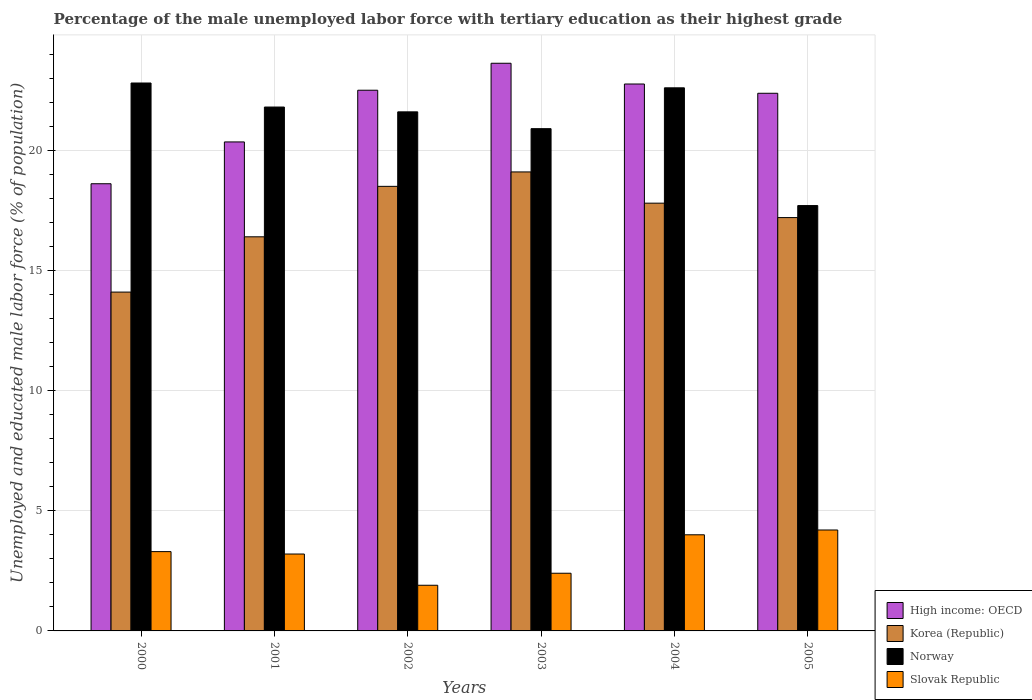How many different coloured bars are there?
Offer a very short reply. 4. How many groups of bars are there?
Your answer should be very brief. 6. Are the number of bars per tick equal to the number of legend labels?
Give a very brief answer. Yes. How many bars are there on the 1st tick from the left?
Keep it short and to the point. 4. How many bars are there on the 6th tick from the right?
Provide a short and direct response. 4. In how many cases, is the number of bars for a given year not equal to the number of legend labels?
Provide a succinct answer. 0. What is the percentage of the unemployed male labor force with tertiary education in Korea (Republic) in 2005?
Give a very brief answer. 17.2. Across all years, what is the maximum percentage of the unemployed male labor force with tertiary education in Norway?
Ensure brevity in your answer.  22.8. Across all years, what is the minimum percentage of the unemployed male labor force with tertiary education in Norway?
Give a very brief answer. 17.7. In which year was the percentage of the unemployed male labor force with tertiary education in Norway maximum?
Ensure brevity in your answer.  2000. What is the total percentage of the unemployed male labor force with tertiary education in Korea (Republic) in the graph?
Your answer should be very brief. 103.1. What is the difference between the percentage of the unemployed male labor force with tertiary education in High income: OECD in 2001 and that in 2005?
Offer a very short reply. -2.02. What is the difference between the percentage of the unemployed male labor force with tertiary education in Slovak Republic in 2005 and the percentage of the unemployed male labor force with tertiary education in High income: OECD in 2003?
Provide a succinct answer. -19.42. What is the average percentage of the unemployed male labor force with tertiary education in Norway per year?
Provide a short and direct response. 21.23. In the year 2005, what is the difference between the percentage of the unemployed male labor force with tertiary education in Slovak Republic and percentage of the unemployed male labor force with tertiary education in Norway?
Your answer should be compact. -13.5. What is the ratio of the percentage of the unemployed male labor force with tertiary education in Slovak Republic in 2001 to that in 2005?
Make the answer very short. 0.76. What is the difference between the highest and the second highest percentage of the unemployed male labor force with tertiary education in Norway?
Offer a terse response. 0.2. What is the difference between the highest and the lowest percentage of the unemployed male labor force with tertiary education in Norway?
Provide a succinct answer. 5.1. In how many years, is the percentage of the unemployed male labor force with tertiary education in Korea (Republic) greater than the average percentage of the unemployed male labor force with tertiary education in Korea (Republic) taken over all years?
Give a very brief answer. 4. Is the sum of the percentage of the unemployed male labor force with tertiary education in High income: OECD in 2003 and 2004 greater than the maximum percentage of the unemployed male labor force with tertiary education in Korea (Republic) across all years?
Keep it short and to the point. Yes. What does the 3rd bar from the right in 2002 represents?
Offer a very short reply. Korea (Republic). Are all the bars in the graph horizontal?
Provide a short and direct response. No. How many years are there in the graph?
Provide a short and direct response. 6. Are the values on the major ticks of Y-axis written in scientific E-notation?
Keep it short and to the point. No. Where does the legend appear in the graph?
Your answer should be very brief. Bottom right. What is the title of the graph?
Your response must be concise. Percentage of the male unemployed labor force with tertiary education as their highest grade. What is the label or title of the Y-axis?
Give a very brief answer. Unemployed and educated male labor force (% of population). What is the Unemployed and educated male labor force (% of population) in High income: OECD in 2000?
Offer a very short reply. 18.61. What is the Unemployed and educated male labor force (% of population) of Korea (Republic) in 2000?
Make the answer very short. 14.1. What is the Unemployed and educated male labor force (% of population) of Norway in 2000?
Offer a terse response. 22.8. What is the Unemployed and educated male labor force (% of population) of Slovak Republic in 2000?
Offer a very short reply. 3.3. What is the Unemployed and educated male labor force (% of population) of High income: OECD in 2001?
Your response must be concise. 20.35. What is the Unemployed and educated male labor force (% of population) in Korea (Republic) in 2001?
Ensure brevity in your answer.  16.4. What is the Unemployed and educated male labor force (% of population) of Norway in 2001?
Offer a very short reply. 21.8. What is the Unemployed and educated male labor force (% of population) of Slovak Republic in 2001?
Your answer should be very brief. 3.2. What is the Unemployed and educated male labor force (% of population) of High income: OECD in 2002?
Keep it short and to the point. 22.5. What is the Unemployed and educated male labor force (% of population) in Norway in 2002?
Your answer should be very brief. 21.6. What is the Unemployed and educated male labor force (% of population) of Slovak Republic in 2002?
Make the answer very short. 1.9. What is the Unemployed and educated male labor force (% of population) of High income: OECD in 2003?
Your answer should be compact. 23.62. What is the Unemployed and educated male labor force (% of population) of Korea (Republic) in 2003?
Keep it short and to the point. 19.1. What is the Unemployed and educated male labor force (% of population) in Norway in 2003?
Ensure brevity in your answer.  20.9. What is the Unemployed and educated male labor force (% of population) in Slovak Republic in 2003?
Provide a short and direct response. 2.4. What is the Unemployed and educated male labor force (% of population) in High income: OECD in 2004?
Keep it short and to the point. 22.76. What is the Unemployed and educated male labor force (% of population) in Korea (Republic) in 2004?
Offer a terse response. 17.8. What is the Unemployed and educated male labor force (% of population) of Norway in 2004?
Provide a succinct answer. 22.6. What is the Unemployed and educated male labor force (% of population) in Slovak Republic in 2004?
Offer a very short reply. 4. What is the Unemployed and educated male labor force (% of population) in High income: OECD in 2005?
Your response must be concise. 22.37. What is the Unemployed and educated male labor force (% of population) in Korea (Republic) in 2005?
Provide a short and direct response. 17.2. What is the Unemployed and educated male labor force (% of population) in Norway in 2005?
Provide a succinct answer. 17.7. What is the Unemployed and educated male labor force (% of population) in Slovak Republic in 2005?
Your answer should be very brief. 4.2. Across all years, what is the maximum Unemployed and educated male labor force (% of population) in High income: OECD?
Your response must be concise. 23.62. Across all years, what is the maximum Unemployed and educated male labor force (% of population) of Korea (Republic)?
Give a very brief answer. 19.1. Across all years, what is the maximum Unemployed and educated male labor force (% of population) of Norway?
Provide a succinct answer. 22.8. Across all years, what is the maximum Unemployed and educated male labor force (% of population) in Slovak Republic?
Your response must be concise. 4.2. Across all years, what is the minimum Unemployed and educated male labor force (% of population) in High income: OECD?
Provide a short and direct response. 18.61. Across all years, what is the minimum Unemployed and educated male labor force (% of population) of Korea (Republic)?
Your answer should be compact. 14.1. Across all years, what is the minimum Unemployed and educated male labor force (% of population) in Norway?
Give a very brief answer. 17.7. Across all years, what is the minimum Unemployed and educated male labor force (% of population) of Slovak Republic?
Keep it short and to the point. 1.9. What is the total Unemployed and educated male labor force (% of population) in High income: OECD in the graph?
Your answer should be very brief. 130.21. What is the total Unemployed and educated male labor force (% of population) of Korea (Republic) in the graph?
Provide a short and direct response. 103.1. What is the total Unemployed and educated male labor force (% of population) of Norway in the graph?
Give a very brief answer. 127.4. What is the total Unemployed and educated male labor force (% of population) of Slovak Republic in the graph?
Make the answer very short. 19. What is the difference between the Unemployed and educated male labor force (% of population) in High income: OECD in 2000 and that in 2001?
Give a very brief answer. -1.74. What is the difference between the Unemployed and educated male labor force (% of population) in Korea (Republic) in 2000 and that in 2001?
Offer a very short reply. -2.3. What is the difference between the Unemployed and educated male labor force (% of population) in Slovak Republic in 2000 and that in 2001?
Your answer should be compact. 0.1. What is the difference between the Unemployed and educated male labor force (% of population) of High income: OECD in 2000 and that in 2002?
Ensure brevity in your answer.  -3.89. What is the difference between the Unemployed and educated male labor force (% of population) of Norway in 2000 and that in 2002?
Provide a succinct answer. 1.2. What is the difference between the Unemployed and educated male labor force (% of population) in Slovak Republic in 2000 and that in 2002?
Your answer should be very brief. 1.4. What is the difference between the Unemployed and educated male labor force (% of population) of High income: OECD in 2000 and that in 2003?
Give a very brief answer. -5.01. What is the difference between the Unemployed and educated male labor force (% of population) in Norway in 2000 and that in 2003?
Ensure brevity in your answer.  1.9. What is the difference between the Unemployed and educated male labor force (% of population) in Slovak Republic in 2000 and that in 2003?
Offer a terse response. 0.9. What is the difference between the Unemployed and educated male labor force (% of population) in High income: OECD in 2000 and that in 2004?
Offer a very short reply. -4.15. What is the difference between the Unemployed and educated male labor force (% of population) in Korea (Republic) in 2000 and that in 2004?
Give a very brief answer. -3.7. What is the difference between the Unemployed and educated male labor force (% of population) of Norway in 2000 and that in 2004?
Offer a very short reply. 0.2. What is the difference between the Unemployed and educated male labor force (% of population) in High income: OECD in 2000 and that in 2005?
Keep it short and to the point. -3.76. What is the difference between the Unemployed and educated male labor force (% of population) in Norway in 2000 and that in 2005?
Ensure brevity in your answer.  5.1. What is the difference between the Unemployed and educated male labor force (% of population) of Slovak Republic in 2000 and that in 2005?
Your response must be concise. -0.9. What is the difference between the Unemployed and educated male labor force (% of population) in High income: OECD in 2001 and that in 2002?
Provide a succinct answer. -2.15. What is the difference between the Unemployed and educated male labor force (% of population) in Slovak Republic in 2001 and that in 2002?
Your response must be concise. 1.3. What is the difference between the Unemployed and educated male labor force (% of population) in High income: OECD in 2001 and that in 2003?
Give a very brief answer. -3.27. What is the difference between the Unemployed and educated male labor force (% of population) of Korea (Republic) in 2001 and that in 2003?
Your response must be concise. -2.7. What is the difference between the Unemployed and educated male labor force (% of population) in Norway in 2001 and that in 2003?
Offer a terse response. 0.9. What is the difference between the Unemployed and educated male labor force (% of population) of Slovak Republic in 2001 and that in 2003?
Make the answer very short. 0.8. What is the difference between the Unemployed and educated male labor force (% of population) in High income: OECD in 2001 and that in 2004?
Offer a very short reply. -2.41. What is the difference between the Unemployed and educated male labor force (% of population) in Korea (Republic) in 2001 and that in 2004?
Your answer should be compact. -1.4. What is the difference between the Unemployed and educated male labor force (% of population) of Norway in 2001 and that in 2004?
Make the answer very short. -0.8. What is the difference between the Unemployed and educated male labor force (% of population) in Slovak Republic in 2001 and that in 2004?
Offer a very short reply. -0.8. What is the difference between the Unemployed and educated male labor force (% of population) of High income: OECD in 2001 and that in 2005?
Give a very brief answer. -2.02. What is the difference between the Unemployed and educated male labor force (% of population) in High income: OECD in 2002 and that in 2003?
Give a very brief answer. -1.12. What is the difference between the Unemployed and educated male labor force (% of population) in Korea (Republic) in 2002 and that in 2003?
Provide a short and direct response. -0.6. What is the difference between the Unemployed and educated male labor force (% of population) in High income: OECD in 2002 and that in 2004?
Provide a short and direct response. -0.26. What is the difference between the Unemployed and educated male labor force (% of population) in Korea (Republic) in 2002 and that in 2004?
Give a very brief answer. 0.7. What is the difference between the Unemployed and educated male labor force (% of population) in Norway in 2002 and that in 2004?
Ensure brevity in your answer.  -1. What is the difference between the Unemployed and educated male labor force (% of population) of High income: OECD in 2002 and that in 2005?
Give a very brief answer. 0.13. What is the difference between the Unemployed and educated male labor force (% of population) in Korea (Republic) in 2002 and that in 2005?
Give a very brief answer. 1.3. What is the difference between the Unemployed and educated male labor force (% of population) of High income: OECD in 2003 and that in 2004?
Provide a succinct answer. 0.86. What is the difference between the Unemployed and educated male labor force (% of population) in Korea (Republic) in 2003 and that in 2004?
Make the answer very short. 1.3. What is the difference between the Unemployed and educated male labor force (% of population) in High income: OECD in 2003 and that in 2005?
Your answer should be compact. 1.25. What is the difference between the Unemployed and educated male labor force (% of population) of Korea (Republic) in 2003 and that in 2005?
Your response must be concise. 1.9. What is the difference between the Unemployed and educated male labor force (% of population) in Norway in 2003 and that in 2005?
Give a very brief answer. 3.2. What is the difference between the Unemployed and educated male labor force (% of population) of High income: OECD in 2004 and that in 2005?
Give a very brief answer. 0.39. What is the difference between the Unemployed and educated male labor force (% of population) in Korea (Republic) in 2004 and that in 2005?
Make the answer very short. 0.6. What is the difference between the Unemployed and educated male labor force (% of population) in Norway in 2004 and that in 2005?
Your answer should be very brief. 4.9. What is the difference between the Unemployed and educated male labor force (% of population) in Slovak Republic in 2004 and that in 2005?
Ensure brevity in your answer.  -0.2. What is the difference between the Unemployed and educated male labor force (% of population) in High income: OECD in 2000 and the Unemployed and educated male labor force (% of population) in Korea (Republic) in 2001?
Make the answer very short. 2.21. What is the difference between the Unemployed and educated male labor force (% of population) in High income: OECD in 2000 and the Unemployed and educated male labor force (% of population) in Norway in 2001?
Make the answer very short. -3.19. What is the difference between the Unemployed and educated male labor force (% of population) of High income: OECD in 2000 and the Unemployed and educated male labor force (% of population) of Slovak Republic in 2001?
Your answer should be very brief. 15.41. What is the difference between the Unemployed and educated male labor force (% of population) in Korea (Republic) in 2000 and the Unemployed and educated male labor force (% of population) in Norway in 2001?
Offer a very short reply. -7.7. What is the difference between the Unemployed and educated male labor force (% of population) of Korea (Republic) in 2000 and the Unemployed and educated male labor force (% of population) of Slovak Republic in 2001?
Ensure brevity in your answer.  10.9. What is the difference between the Unemployed and educated male labor force (% of population) in Norway in 2000 and the Unemployed and educated male labor force (% of population) in Slovak Republic in 2001?
Offer a very short reply. 19.6. What is the difference between the Unemployed and educated male labor force (% of population) of High income: OECD in 2000 and the Unemployed and educated male labor force (% of population) of Korea (Republic) in 2002?
Ensure brevity in your answer.  0.11. What is the difference between the Unemployed and educated male labor force (% of population) in High income: OECD in 2000 and the Unemployed and educated male labor force (% of population) in Norway in 2002?
Provide a short and direct response. -2.99. What is the difference between the Unemployed and educated male labor force (% of population) in High income: OECD in 2000 and the Unemployed and educated male labor force (% of population) in Slovak Republic in 2002?
Make the answer very short. 16.71. What is the difference between the Unemployed and educated male labor force (% of population) of Korea (Republic) in 2000 and the Unemployed and educated male labor force (% of population) of Norway in 2002?
Your answer should be compact. -7.5. What is the difference between the Unemployed and educated male labor force (% of population) in Norway in 2000 and the Unemployed and educated male labor force (% of population) in Slovak Republic in 2002?
Provide a succinct answer. 20.9. What is the difference between the Unemployed and educated male labor force (% of population) in High income: OECD in 2000 and the Unemployed and educated male labor force (% of population) in Korea (Republic) in 2003?
Provide a succinct answer. -0.49. What is the difference between the Unemployed and educated male labor force (% of population) in High income: OECD in 2000 and the Unemployed and educated male labor force (% of population) in Norway in 2003?
Provide a short and direct response. -2.29. What is the difference between the Unemployed and educated male labor force (% of population) in High income: OECD in 2000 and the Unemployed and educated male labor force (% of population) in Slovak Republic in 2003?
Offer a very short reply. 16.21. What is the difference between the Unemployed and educated male labor force (% of population) of Korea (Republic) in 2000 and the Unemployed and educated male labor force (% of population) of Norway in 2003?
Ensure brevity in your answer.  -6.8. What is the difference between the Unemployed and educated male labor force (% of population) in Korea (Republic) in 2000 and the Unemployed and educated male labor force (% of population) in Slovak Republic in 2003?
Your answer should be compact. 11.7. What is the difference between the Unemployed and educated male labor force (% of population) of Norway in 2000 and the Unemployed and educated male labor force (% of population) of Slovak Republic in 2003?
Offer a terse response. 20.4. What is the difference between the Unemployed and educated male labor force (% of population) of High income: OECD in 2000 and the Unemployed and educated male labor force (% of population) of Korea (Republic) in 2004?
Keep it short and to the point. 0.81. What is the difference between the Unemployed and educated male labor force (% of population) of High income: OECD in 2000 and the Unemployed and educated male labor force (% of population) of Norway in 2004?
Your answer should be very brief. -3.99. What is the difference between the Unemployed and educated male labor force (% of population) in High income: OECD in 2000 and the Unemployed and educated male labor force (% of population) in Slovak Republic in 2004?
Your answer should be very brief. 14.61. What is the difference between the Unemployed and educated male labor force (% of population) in Korea (Republic) in 2000 and the Unemployed and educated male labor force (% of population) in Slovak Republic in 2004?
Offer a very short reply. 10.1. What is the difference between the Unemployed and educated male labor force (% of population) of Norway in 2000 and the Unemployed and educated male labor force (% of population) of Slovak Republic in 2004?
Give a very brief answer. 18.8. What is the difference between the Unemployed and educated male labor force (% of population) of High income: OECD in 2000 and the Unemployed and educated male labor force (% of population) of Korea (Republic) in 2005?
Offer a very short reply. 1.41. What is the difference between the Unemployed and educated male labor force (% of population) of High income: OECD in 2000 and the Unemployed and educated male labor force (% of population) of Norway in 2005?
Ensure brevity in your answer.  0.91. What is the difference between the Unemployed and educated male labor force (% of population) of High income: OECD in 2000 and the Unemployed and educated male labor force (% of population) of Slovak Republic in 2005?
Your answer should be compact. 14.41. What is the difference between the Unemployed and educated male labor force (% of population) in Korea (Republic) in 2000 and the Unemployed and educated male labor force (% of population) in Norway in 2005?
Offer a very short reply. -3.6. What is the difference between the Unemployed and educated male labor force (% of population) in Norway in 2000 and the Unemployed and educated male labor force (% of population) in Slovak Republic in 2005?
Your answer should be very brief. 18.6. What is the difference between the Unemployed and educated male labor force (% of population) of High income: OECD in 2001 and the Unemployed and educated male labor force (% of population) of Korea (Republic) in 2002?
Provide a short and direct response. 1.85. What is the difference between the Unemployed and educated male labor force (% of population) in High income: OECD in 2001 and the Unemployed and educated male labor force (% of population) in Norway in 2002?
Your response must be concise. -1.25. What is the difference between the Unemployed and educated male labor force (% of population) of High income: OECD in 2001 and the Unemployed and educated male labor force (% of population) of Slovak Republic in 2002?
Keep it short and to the point. 18.45. What is the difference between the Unemployed and educated male labor force (% of population) of Korea (Republic) in 2001 and the Unemployed and educated male labor force (% of population) of Slovak Republic in 2002?
Give a very brief answer. 14.5. What is the difference between the Unemployed and educated male labor force (% of population) of High income: OECD in 2001 and the Unemployed and educated male labor force (% of population) of Korea (Republic) in 2003?
Make the answer very short. 1.25. What is the difference between the Unemployed and educated male labor force (% of population) of High income: OECD in 2001 and the Unemployed and educated male labor force (% of population) of Norway in 2003?
Your answer should be compact. -0.55. What is the difference between the Unemployed and educated male labor force (% of population) in High income: OECD in 2001 and the Unemployed and educated male labor force (% of population) in Slovak Republic in 2003?
Ensure brevity in your answer.  17.95. What is the difference between the Unemployed and educated male labor force (% of population) of Norway in 2001 and the Unemployed and educated male labor force (% of population) of Slovak Republic in 2003?
Offer a very short reply. 19.4. What is the difference between the Unemployed and educated male labor force (% of population) in High income: OECD in 2001 and the Unemployed and educated male labor force (% of population) in Korea (Republic) in 2004?
Your answer should be very brief. 2.55. What is the difference between the Unemployed and educated male labor force (% of population) of High income: OECD in 2001 and the Unemployed and educated male labor force (% of population) of Norway in 2004?
Offer a terse response. -2.25. What is the difference between the Unemployed and educated male labor force (% of population) of High income: OECD in 2001 and the Unemployed and educated male labor force (% of population) of Slovak Republic in 2004?
Offer a terse response. 16.35. What is the difference between the Unemployed and educated male labor force (% of population) in Norway in 2001 and the Unemployed and educated male labor force (% of population) in Slovak Republic in 2004?
Offer a very short reply. 17.8. What is the difference between the Unemployed and educated male labor force (% of population) of High income: OECD in 2001 and the Unemployed and educated male labor force (% of population) of Korea (Republic) in 2005?
Your response must be concise. 3.15. What is the difference between the Unemployed and educated male labor force (% of population) of High income: OECD in 2001 and the Unemployed and educated male labor force (% of population) of Norway in 2005?
Your answer should be compact. 2.65. What is the difference between the Unemployed and educated male labor force (% of population) of High income: OECD in 2001 and the Unemployed and educated male labor force (% of population) of Slovak Republic in 2005?
Provide a succinct answer. 16.15. What is the difference between the Unemployed and educated male labor force (% of population) of Korea (Republic) in 2001 and the Unemployed and educated male labor force (% of population) of Slovak Republic in 2005?
Make the answer very short. 12.2. What is the difference between the Unemployed and educated male labor force (% of population) in High income: OECD in 2002 and the Unemployed and educated male labor force (% of population) in Korea (Republic) in 2003?
Provide a succinct answer. 3.4. What is the difference between the Unemployed and educated male labor force (% of population) in High income: OECD in 2002 and the Unemployed and educated male labor force (% of population) in Norway in 2003?
Your answer should be compact. 1.6. What is the difference between the Unemployed and educated male labor force (% of population) of High income: OECD in 2002 and the Unemployed and educated male labor force (% of population) of Slovak Republic in 2003?
Keep it short and to the point. 20.1. What is the difference between the Unemployed and educated male labor force (% of population) of Korea (Republic) in 2002 and the Unemployed and educated male labor force (% of population) of Norway in 2003?
Make the answer very short. -2.4. What is the difference between the Unemployed and educated male labor force (% of population) in Korea (Republic) in 2002 and the Unemployed and educated male labor force (% of population) in Slovak Republic in 2003?
Offer a terse response. 16.1. What is the difference between the Unemployed and educated male labor force (% of population) of Norway in 2002 and the Unemployed and educated male labor force (% of population) of Slovak Republic in 2003?
Provide a short and direct response. 19.2. What is the difference between the Unemployed and educated male labor force (% of population) of High income: OECD in 2002 and the Unemployed and educated male labor force (% of population) of Korea (Republic) in 2004?
Provide a succinct answer. 4.7. What is the difference between the Unemployed and educated male labor force (% of population) of High income: OECD in 2002 and the Unemployed and educated male labor force (% of population) of Norway in 2004?
Your answer should be compact. -0.1. What is the difference between the Unemployed and educated male labor force (% of population) of High income: OECD in 2002 and the Unemployed and educated male labor force (% of population) of Slovak Republic in 2004?
Make the answer very short. 18.5. What is the difference between the Unemployed and educated male labor force (% of population) of High income: OECD in 2002 and the Unemployed and educated male labor force (% of population) of Korea (Republic) in 2005?
Give a very brief answer. 5.3. What is the difference between the Unemployed and educated male labor force (% of population) of High income: OECD in 2002 and the Unemployed and educated male labor force (% of population) of Norway in 2005?
Your answer should be compact. 4.8. What is the difference between the Unemployed and educated male labor force (% of population) in High income: OECD in 2002 and the Unemployed and educated male labor force (% of population) in Slovak Republic in 2005?
Provide a succinct answer. 18.3. What is the difference between the Unemployed and educated male labor force (% of population) of Korea (Republic) in 2002 and the Unemployed and educated male labor force (% of population) of Norway in 2005?
Your answer should be very brief. 0.8. What is the difference between the Unemployed and educated male labor force (% of population) in High income: OECD in 2003 and the Unemployed and educated male labor force (% of population) in Korea (Republic) in 2004?
Offer a terse response. 5.82. What is the difference between the Unemployed and educated male labor force (% of population) of High income: OECD in 2003 and the Unemployed and educated male labor force (% of population) of Norway in 2004?
Offer a very short reply. 1.02. What is the difference between the Unemployed and educated male labor force (% of population) of High income: OECD in 2003 and the Unemployed and educated male labor force (% of population) of Slovak Republic in 2004?
Make the answer very short. 19.62. What is the difference between the Unemployed and educated male labor force (% of population) in High income: OECD in 2003 and the Unemployed and educated male labor force (% of population) in Korea (Republic) in 2005?
Offer a terse response. 6.42. What is the difference between the Unemployed and educated male labor force (% of population) of High income: OECD in 2003 and the Unemployed and educated male labor force (% of population) of Norway in 2005?
Give a very brief answer. 5.92. What is the difference between the Unemployed and educated male labor force (% of population) of High income: OECD in 2003 and the Unemployed and educated male labor force (% of population) of Slovak Republic in 2005?
Give a very brief answer. 19.42. What is the difference between the Unemployed and educated male labor force (% of population) in Norway in 2003 and the Unemployed and educated male labor force (% of population) in Slovak Republic in 2005?
Ensure brevity in your answer.  16.7. What is the difference between the Unemployed and educated male labor force (% of population) in High income: OECD in 2004 and the Unemployed and educated male labor force (% of population) in Korea (Republic) in 2005?
Give a very brief answer. 5.56. What is the difference between the Unemployed and educated male labor force (% of population) in High income: OECD in 2004 and the Unemployed and educated male labor force (% of population) in Norway in 2005?
Provide a short and direct response. 5.06. What is the difference between the Unemployed and educated male labor force (% of population) in High income: OECD in 2004 and the Unemployed and educated male labor force (% of population) in Slovak Republic in 2005?
Offer a terse response. 18.56. What is the average Unemployed and educated male labor force (% of population) of High income: OECD per year?
Your answer should be very brief. 21.7. What is the average Unemployed and educated male labor force (% of population) in Korea (Republic) per year?
Your answer should be very brief. 17.18. What is the average Unemployed and educated male labor force (% of population) of Norway per year?
Your answer should be very brief. 21.23. What is the average Unemployed and educated male labor force (% of population) of Slovak Republic per year?
Offer a very short reply. 3.17. In the year 2000, what is the difference between the Unemployed and educated male labor force (% of population) in High income: OECD and Unemployed and educated male labor force (% of population) in Korea (Republic)?
Your response must be concise. 4.51. In the year 2000, what is the difference between the Unemployed and educated male labor force (% of population) in High income: OECD and Unemployed and educated male labor force (% of population) in Norway?
Your answer should be very brief. -4.19. In the year 2000, what is the difference between the Unemployed and educated male labor force (% of population) in High income: OECD and Unemployed and educated male labor force (% of population) in Slovak Republic?
Your answer should be very brief. 15.31. In the year 2001, what is the difference between the Unemployed and educated male labor force (% of population) in High income: OECD and Unemployed and educated male labor force (% of population) in Korea (Republic)?
Offer a very short reply. 3.95. In the year 2001, what is the difference between the Unemployed and educated male labor force (% of population) of High income: OECD and Unemployed and educated male labor force (% of population) of Norway?
Keep it short and to the point. -1.45. In the year 2001, what is the difference between the Unemployed and educated male labor force (% of population) in High income: OECD and Unemployed and educated male labor force (% of population) in Slovak Republic?
Your answer should be compact. 17.15. In the year 2002, what is the difference between the Unemployed and educated male labor force (% of population) in High income: OECD and Unemployed and educated male labor force (% of population) in Korea (Republic)?
Provide a succinct answer. 4. In the year 2002, what is the difference between the Unemployed and educated male labor force (% of population) in High income: OECD and Unemployed and educated male labor force (% of population) in Norway?
Provide a succinct answer. 0.9. In the year 2002, what is the difference between the Unemployed and educated male labor force (% of population) of High income: OECD and Unemployed and educated male labor force (% of population) of Slovak Republic?
Ensure brevity in your answer.  20.6. In the year 2002, what is the difference between the Unemployed and educated male labor force (% of population) of Korea (Republic) and Unemployed and educated male labor force (% of population) of Norway?
Your answer should be very brief. -3.1. In the year 2003, what is the difference between the Unemployed and educated male labor force (% of population) in High income: OECD and Unemployed and educated male labor force (% of population) in Korea (Republic)?
Give a very brief answer. 4.52. In the year 2003, what is the difference between the Unemployed and educated male labor force (% of population) of High income: OECD and Unemployed and educated male labor force (% of population) of Norway?
Ensure brevity in your answer.  2.72. In the year 2003, what is the difference between the Unemployed and educated male labor force (% of population) of High income: OECD and Unemployed and educated male labor force (% of population) of Slovak Republic?
Your response must be concise. 21.22. In the year 2003, what is the difference between the Unemployed and educated male labor force (% of population) in Korea (Republic) and Unemployed and educated male labor force (% of population) in Norway?
Your response must be concise. -1.8. In the year 2003, what is the difference between the Unemployed and educated male labor force (% of population) of Norway and Unemployed and educated male labor force (% of population) of Slovak Republic?
Provide a succinct answer. 18.5. In the year 2004, what is the difference between the Unemployed and educated male labor force (% of population) in High income: OECD and Unemployed and educated male labor force (% of population) in Korea (Republic)?
Offer a terse response. 4.96. In the year 2004, what is the difference between the Unemployed and educated male labor force (% of population) of High income: OECD and Unemployed and educated male labor force (% of population) of Norway?
Offer a terse response. 0.16. In the year 2004, what is the difference between the Unemployed and educated male labor force (% of population) in High income: OECD and Unemployed and educated male labor force (% of population) in Slovak Republic?
Make the answer very short. 18.76. In the year 2004, what is the difference between the Unemployed and educated male labor force (% of population) of Korea (Republic) and Unemployed and educated male labor force (% of population) of Slovak Republic?
Offer a very short reply. 13.8. In the year 2005, what is the difference between the Unemployed and educated male labor force (% of population) in High income: OECD and Unemployed and educated male labor force (% of population) in Korea (Republic)?
Your response must be concise. 5.17. In the year 2005, what is the difference between the Unemployed and educated male labor force (% of population) of High income: OECD and Unemployed and educated male labor force (% of population) of Norway?
Your response must be concise. 4.67. In the year 2005, what is the difference between the Unemployed and educated male labor force (% of population) of High income: OECD and Unemployed and educated male labor force (% of population) of Slovak Republic?
Keep it short and to the point. 18.17. What is the ratio of the Unemployed and educated male labor force (% of population) of High income: OECD in 2000 to that in 2001?
Make the answer very short. 0.91. What is the ratio of the Unemployed and educated male labor force (% of population) in Korea (Republic) in 2000 to that in 2001?
Give a very brief answer. 0.86. What is the ratio of the Unemployed and educated male labor force (% of population) in Norway in 2000 to that in 2001?
Provide a succinct answer. 1.05. What is the ratio of the Unemployed and educated male labor force (% of population) in Slovak Republic in 2000 to that in 2001?
Your answer should be compact. 1.03. What is the ratio of the Unemployed and educated male labor force (% of population) of High income: OECD in 2000 to that in 2002?
Your answer should be very brief. 0.83. What is the ratio of the Unemployed and educated male labor force (% of population) of Korea (Republic) in 2000 to that in 2002?
Provide a short and direct response. 0.76. What is the ratio of the Unemployed and educated male labor force (% of population) of Norway in 2000 to that in 2002?
Ensure brevity in your answer.  1.06. What is the ratio of the Unemployed and educated male labor force (% of population) in Slovak Republic in 2000 to that in 2002?
Give a very brief answer. 1.74. What is the ratio of the Unemployed and educated male labor force (% of population) in High income: OECD in 2000 to that in 2003?
Offer a terse response. 0.79. What is the ratio of the Unemployed and educated male labor force (% of population) in Korea (Republic) in 2000 to that in 2003?
Ensure brevity in your answer.  0.74. What is the ratio of the Unemployed and educated male labor force (% of population) of Slovak Republic in 2000 to that in 2003?
Make the answer very short. 1.38. What is the ratio of the Unemployed and educated male labor force (% of population) in High income: OECD in 2000 to that in 2004?
Give a very brief answer. 0.82. What is the ratio of the Unemployed and educated male labor force (% of population) of Korea (Republic) in 2000 to that in 2004?
Offer a terse response. 0.79. What is the ratio of the Unemployed and educated male labor force (% of population) in Norway in 2000 to that in 2004?
Your answer should be very brief. 1.01. What is the ratio of the Unemployed and educated male labor force (% of population) of Slovak Republic in 2000 to that in 2004?
Your response must be concise. 0.82. What is the ratio of the Unemployed and educated male labor force (% of population) of High income: OECD in 2000 to that in 2005?
Provide a succinct answer. 0.83. What is the ratio of the Unemployed and educated male labor force (% of population) of Korea (Republic) in 2000 to that in 2005?
Provide a succinct answer. 0.82. What is the ratio of the Unemployed and educated male labor force (% of population) of Norway in 2000 to that in 2005?
Ensure brevity in your answer.  1.29. What is the ratio of the Unemployed and educated male labor force (% of population) in Slovak Republic in 2000 to that in 2005?
Keep it short and to the point. 0.79. What is the ratio of the Unemployed and educated male labor force (% of population) in High income: OECD in 2001 to that in 2002?
Offer a very short reply. 0.9. What is the ratio of the Unemployed and educated male labor force (% of population) of Korea (Republic) in 2001 to that in 2002?
Offer a terse response. 0.89. What is the ratio of the Unemployed and educated male labor force (% of population) in Norway in 2001 to that in 2002?
Offer a very short reply. 1.01. What is the ratio of the Unemployed and educated male labor force (% of population) of Slovak Republic in 2001 to that in 2002?
Offer a terse response. 1.68. What is the ratio of the Unemployed and educated male labor force (% of population) in High income: OECD in 2001 to that in 2003?
Give a very brief answer. 0.86. What is the ratio of the Unemployed and educated male labor force (% of population) in Korea (Republic) in 2001 to that in 2003?
Your response must be concise. 0.86. What is the ratio of the Unemployed and educated male labor force (% of population) of Norway in 2001 to that in 2003?
Provide a succinct answer. 1.04. What is the ratio of the Unemployed and educated male labor force (% of population) of Slovak Republic in 2001 to that in 2003?
Keep it short and to the point. 1.33. What is the ratio of the Unemployed and educated male labor force (% of population) of High income: OECD in 2001 to that in 2004?
Give a very brief answer. 0.89. What is the ratio of the Unemployed and educated male labor force (% of population) of Korea (Republic) in 2001 to that in 2004?
Keep it short and to the point. 0.92. What is the ratio of the Unemployed and educated male labor force (% of population) of Norway in 2001 to that in 2004?
Keep it short and to the point. 0.96. What is the ratio of the Unemployed and educated male labor force (% of population) in Slovak Republic in 2001 to that in 2004?
Ensure brevity in your answer.  0.8. What is the ratio of the Unemployed and educated male labor force (% of population) in High income: OECD in 2001 to that in 2005?
Give a very brief answer. 0.91. What is the ratio of the Unemployed and educated male labor force (% of population) in Korea (Republic) in 2001 to that in 2005?
Ensure brevity in your answer.  0.95. What is the ratio of the Unemployed and educated male labor force (% of population) in Norway in 2001 to that in 2005?
Your answer should be compact. 1.23. What is the ratio of the Unemployed and educated male labor force (% of population) in Slovak Republic in 2001 to that in 2005?
Your answer should be very brief. 0.76. What is the ratio of the Unemployed and educated male labor force (% of population) in High income: OECD in 2002 to that in 2003?
Ensure brevity in your answer.  0.95. What is the ratio of the Unemployed and educated male labor force (% of population) of Korea (Republic) in 2002 to that in 2003?
Your response must be concise. 0.97. What is the ratio of the Unemployed and educated male labor force (% of population) of Norway in 2002 to that in 2003?
Give a very brief answer. 1.03. What is the ratio of the Unemployed and educated male labor force (% of population) of Slovak Republic in 2002 to that in 2003?
Make the answer very short. 0.79. What is the ratio of the Unemployed and educated male labor force (% of population) of Korea (Republic) in 2002 to that in 2004?
Offer a terse response. 1.04. What is the ratio of the Unemployed and educated male labor force (% of population) of Norway in 2002 to that in 2004?
Ensure brevity in your answer.  0.96. What is the ratio of the Unemployed and educated male labor force (% of population) in Slovak Republic in 2002 to that in 2004?
Keep it short and to the point. 0.47. What is the ratio of the Unemployed and educated male labor force (% of population) of Korea (Republic) in 2002 to that in 2005?
Offer a very short reply. 1.08. What is the ratio of the Unemployed and educated male labor force (% of population) in Norway in 2002 to that in 2005?
Offer a terse response. 1.22. What is the ratio of the Unemployed and educated male labor force (% of population) in Slovak Republic in 2002 to that in 2005?
Provide a short and direct response. 0.45. What is the ratio of the Unemployed and educated male labor force (% of population) in High income: OECD in 2003 to that in 2004?
Make the answer very short. 1.04. What is the ratio of the Unemployed and educated male labor force (% of population) in Korea (Republic) in 2003 to that in 2004?
Your answer should be compact. 1.07. What is the ratio of the Unemployed and educated male labor force (% of population) in Norway in 2003 to that in 2004?
Offer a very short reply. 0.92. What is the ratio of the Unemployed and educated male labor force (% of population) of Slovak Republic in 2003 to that in 2004?
Keep it short and to the point. 0.6. What is the ratio of the Unemployed and educated male labor force (% of population) of High income: OECD in 2003 to that in 2005?
Give a very brief answer. 1.06. What is the ratio of the Unemployed and educated male labor force (% of population) of Korea (Republic) in 2003 to that in 2005?
Offer a very short reply. 1.11. What is the ratio of the Unemployed and educated male labor force (% of population) in Norway in 2003 to that in 2005?
Your answer should be very brief. 1.18. What is the ratio of the Unemployed and educated male labor force (% of population) in High income: OECD in 2004 to that in 2005?
Offer a very short reply. 1.02. What is the ratio of the Unemployed and educated male labor force (% of population) of Korea (Republic) in 2004 to that in 2005?
Keep it short and to the point. 1.03. What is the ratio of the Unemployed and educated male labor force (% of population) in Norway in 2004 to that in 2005?
Make the answer very short. 1.28. What is the ratio of the Unemployed and educated male labor force (% of population) in Slovak Republic in 2004 to that in 2005?
Make the answer very short. 0.95. What is the difference between the highest and the second highest Unemployed and educated male labor force (% of population) of High income: OECD?
Provide a succinct answer. 0.86. What is the difference between the highest and the second highest Unemployed and educated male labor force (% of population) of Korea (Republic)?
Give a very brief answer. 0.6. What is the difference between the highest and the second highest Unemployed and educated male labor force (% of population) of Norway?
Ensure brevity in your answer.  0.2. What is the difference between the highest and the second highest Unemployed and educated male labor force (% of population) of Slovak Republic?
Give a very brief answer. 0.2. What is the difference between the highest and the lowest Unemployed and educated male labor force (% of population) of High income: OECD?
Provide a short and direct response. 5.01. What is the difference between the highest and the lowest Unemployed and educated male labor force (% of population) in Norway?
Your answer should be very brief. 5.1. What is the difference between the highest and the lowest Unemployed and educated male labor force (% of population) in Slovak Republic?
Offer a terse response. 2.3. 